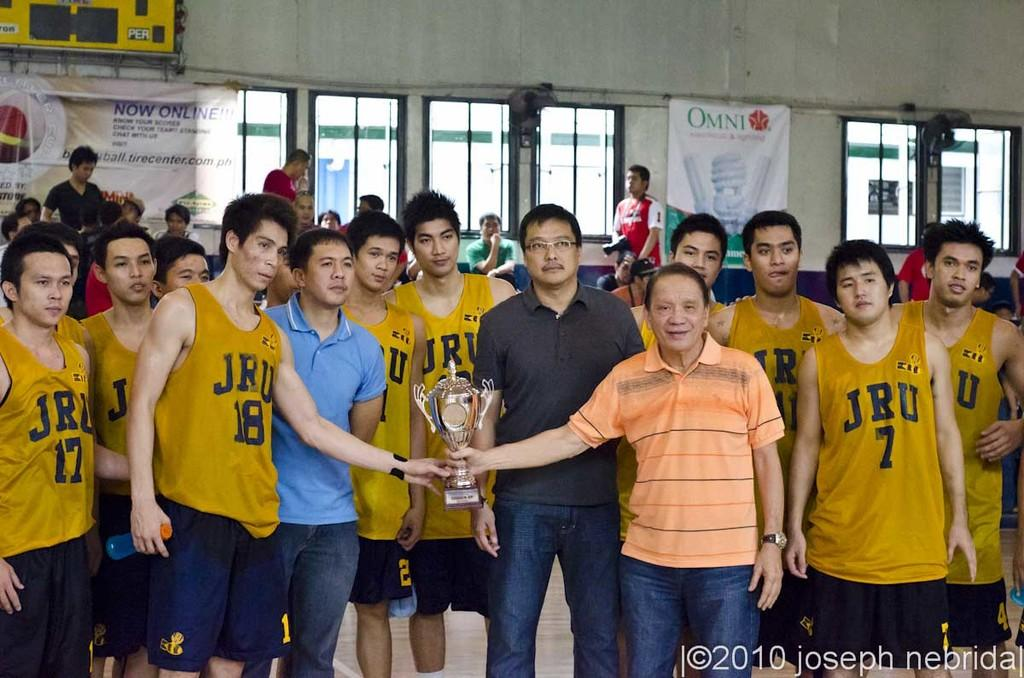Provide a one-sentence caption for the provided image. JRU TEAM IN A GYM WITH ONE TEAM MEMBER AND MAN IN ORANGE POLO HOLDING ONTO TROPHY. 